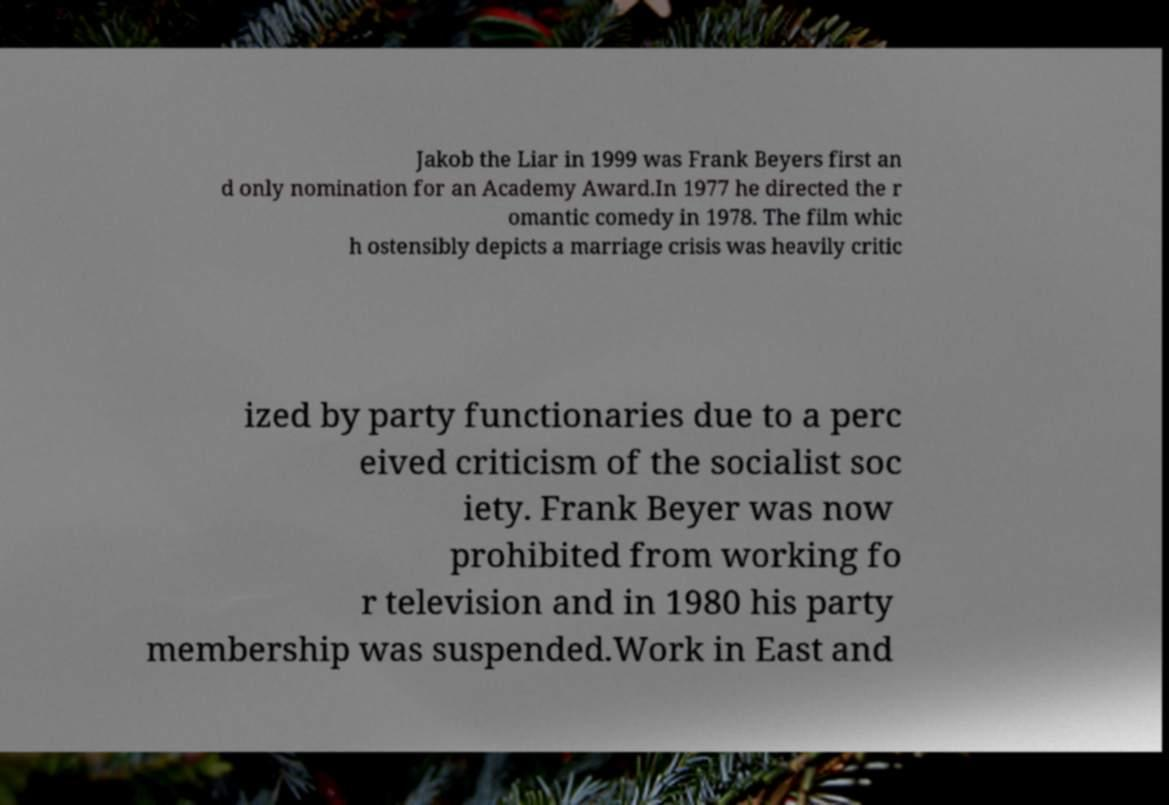Please identify and transcribe the text found in this image. Jakob the Liar in 1999 was Frank Beyers first an d only nomination for an Academy Award.In 1977 he directed the r omantic comedy in 1978. The film whic h ostensibly depicts a marriage crisis was heavily critic ized by party functionaries due to a perc eived criticism of the socialist soc iety. Frank Beyer was now prohibited from working fo r television and in 1980 his party membership was suspended.Work in East and 